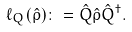Convert formula to latex. <formula><loc_0><loc_0><loc_500><loc_500>\ell _ { Q } ( \hat { \rho } ) \colon = \hat { Q } \hat { \rho } \hat { Q } ^ { \dagger } .</formula> 